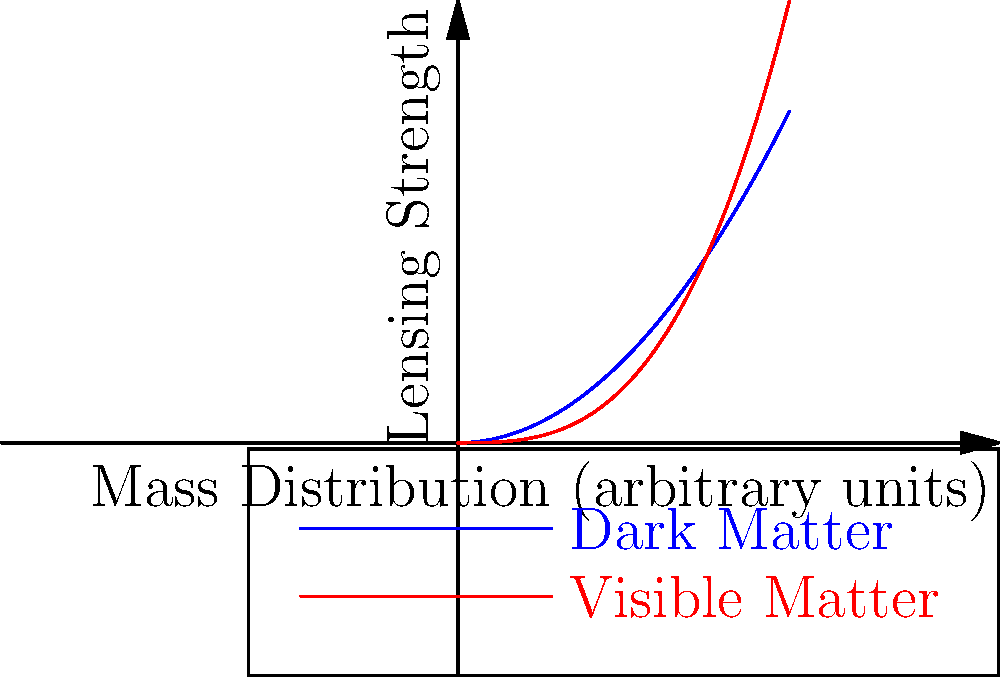Based on the graph showing the relationship between mass distribution and lensing strength for dark matter and visible matter in a galaxy cluster, what can be inferred about the distribution of dark matter compared to visible matter? How might this information be used in an astrophysical plot development? To answer this question, let's analyze the graph step-by-step:

1. The x-axis represents the mass distribution in arbitrary units, while the y-axis shows the lensing strength.

2. Two curves are plotted: blue for dark matter and red for visible matter.

3. The dark matter curve (blue) follows a quadratic function: $y = 0.5x^2$

4. The visible matter curve (red) follows a cubic function: $y = \frac{x^3}{3}$

5. For lower mass distributions (x < 1), the dark matter curve shows higher lensing strength than visible matter.

6. As mass distribution increases (x > 1), the visible matter curve overtakes the dark matter curve in lensing strength.

7. This implies that dark matter has a more significant gravitational lensing effect at lower mass concentrations, while visible matter dominates at higher mass concentrations.

8. In a plot development, this could be used to create a scenario where:
   a) A seemingly empty region of space has unexpectedly strong gravitational lensing, hinting at a hidden concentration of dark matter.
   b) Characters might use this knowledge to navigate through space, avoiding or utilizing these dark matter concentrations.
   c) The discovery of an anomalous region where visible matter dominates unexpectedly could be a plot point, potentially indicating a unique cosmic phenomenon or alien technology manipulating matter distribution.
Answer: Dark matter dominates lensing at lower mass concentrations; visible matter at higher concentrations. Plot potential: hidden dark matter regions, space navigation, or anomalous visible matter concentrations. 